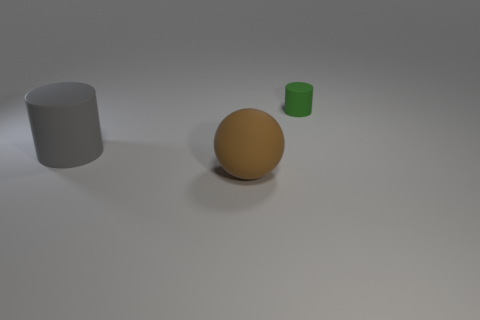Add 1 tiny green things. How many objects exist? 4 Subtract all spheres. How many objects are left? 2 Subtract all large shiny spheres. Subtract all big cylinders. How many objects are left? 2 Add 3 green things. How many green things are left? 4 Add 3 big gray cylinders. How many big gray cylinders exist? 4 Subtract 0 brown cylinders. How many objects are left? 3 